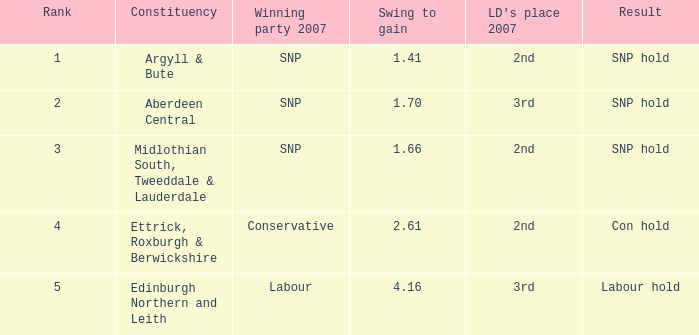What is the lowest rank when the constituency is edinburgh northern and leith and the swing to gain is less than 4.16? None. 